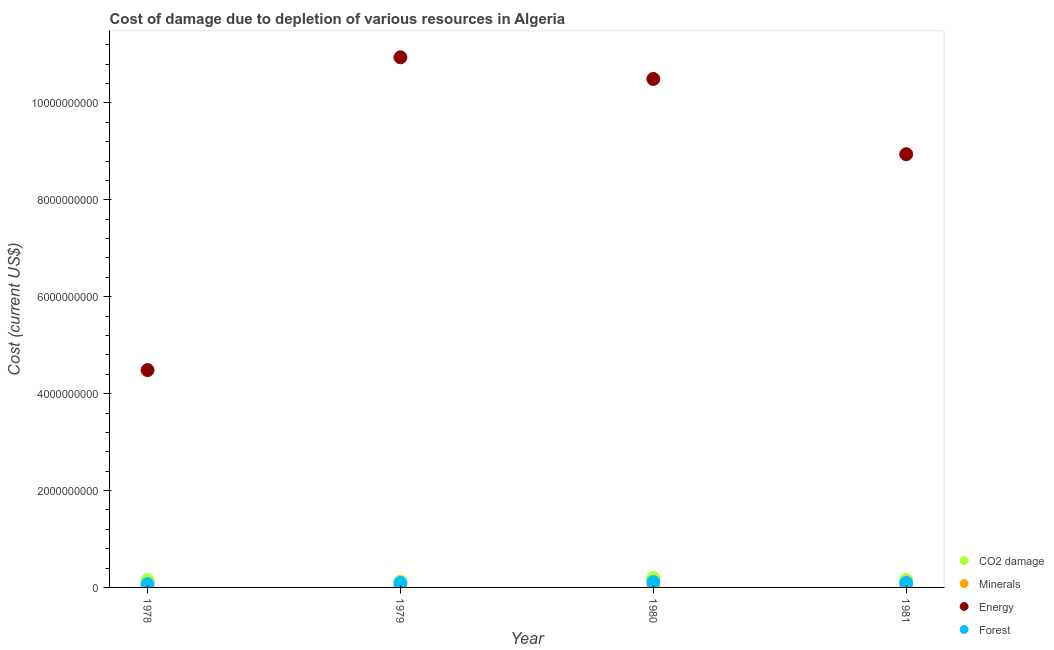How many different coloured dotlines are there?
Offer a terse response. 4. Is the number of dotlines equal to the number of legend labels?
Your response must be concise. Yes. What is the cost of damage due to depletion of minerals in 1980?
Ensure brevity in your answer.  1.57e+07. Across all years, what is the maximum cost of damage due to depletion of coal?
Give a very brief answer. 1.94e+08. Across all years, what is the minimum cost of damage due to depletion of forests?
Your answer should be very brief. 6.78e+07. In which year was the cost of damage due to depletion of energy maximum?
Your response must be concise. 1979. In which year was the cost of damage due to depletion of forests minimum?
Your answer should be very brief. 1978. What is the total cost of damage due to depletion of energy in the graph?
Provide a short and direct response. 3.49e+1. What is the difference between the cost of damage due to depletion of forests in 1979 and that in 1980?
Your answer should be very brief. -2.06e+07. What is the difference between the cost of damage due to depletion of energy in 1979 and the cost of damage due to depletion of forests in 1978?
Make the answer very short. 1.09e+1. What is the average cost of damage due to depletion of energy per year?
Your answer should be very brief. 8.72e+09. In the year 1980, what is the difference between the cost of damage due to depletion of minerals and cost of damage due to depletion of forests?
Offer a very short reply. -9.63e+07. In how many years, is the cost of damage due to depletion of minerals greater than 10000000000 US$?
Your answer should be very brief. 0. What is the ratio of the cost of damage due to depletion of forests in 1978 to that in 1979?
Offer a very short reply. 0.74. Is the difference between the cost of damage due to depletion of energy in 1978 and 1979 greater than the difference between the cost of damage due to depletion of minerals in 1978 and 1979?
Offer a very short reply. No. What is the difference between the highest and the second highest cost of damage due to depletion of energy?
Provide a succinct answer. 4.47e+08. What is the difference between the highest and the lowest cost of damage due to depletion of minerals?
Ensure brevity in your answer.  7.98e+06. In how many years, is the cost of damage due to depletion of coal greater than the average cost of damage due to depletion of coal taken over all years?
Ensure brevity in your answer.  1. Is the cost of damage due to depletion of forests strictly greater than the cost of damage due to depletion of energy over the years?
Provide a succinct answer. No. Is the cost of damage due to depletion of minerals strictly less than the cost of damage due to depletion of energy over the years?
Offer a terse response. Yes. What is the difference between two consecutive major ticks on the Y-axis?
Make the answer very short. 2.00e+09. Are the values on the major ticks of Y-axis written in scientific E-notation?
Give a very brief answer. No. Does the graph contain grids?
Offer a terse response. No. How many legend labels are there?
Ensure brevity in your answer.  4. How are the legend labels stacked?
Provide a succinct answer. Vertical. What is the title of the graph?
Your answer should be compact. Cost of damage due to depletion of various resources in Algeria . Does "Japan" appear as one of the legend labels in the graph?
Your response must be concise. No. What is the label or title of the Y-axis?
Your answer should be compact. Cost (current US$). What is the Cost (current US$) in CO2 damage in 1978?
Provide a succinct answer. 1.51e+08. What is the Cost (current US$) in Minerals in 1978?
Offer a terse response. 7.76e+06. What is the Cost (current US$) in Energy in 1978?
Offer a very short reply. 4.49e+09. What is the Cost (current US$) in Forest in 1978?
Your response must be concise. 6.78e+07. What is the Cost (current US$) in CO2 damage in 1979?
Make the answer very short. 1.21e+08. What is the Cost (current US$) in Minerals in 1979?
Offer a terse response. 9.02e+06. What is the Cost (current US$) in Energy in 1979?
Your response must be concise. 1.09e+1. What is the Cost (current US$) in Forest in 1979?
Your answer should be very brief. 9.15e+07. What is the Cost (current US$) in CO2 damage in 1980?
Provide a succinct answer. 1.94e+08. What is the Cost (current US$) of Minerals in 1980?
Offer a terse response. 1.57e+07. What is the Cost (current US$) in Energy in 1980?
Keep it short and to the point. 1.05e+1. What is the Cost (current US$) of Forest in 1980?
Ensure brevity in your answer.  1.12e+08. What is the Cost (current US$) of CO2 damage in 1981?
Provide a succinct answer. 1.50e+08. What is the Cost (current US$) in Minerals in 1981?
Offer a terse response. 1.55e+07. What is the Cost (current US$) in Energy in 1981?
Offer a very short reply. 8.94e+09. What is the Cost (current US$) in Forest in 1981?
Your answer should be very brief. 9.29e+07. Across all years, what is the maximum Cost (current US$) of CO2 damage?
Make the answer very short. 1.94e+08. Across all years, what is the maximum Cost (current US$) of Minerals?
Keep it short and to the point. 1.57e+07. Across all years, what is the maximum Cost (current US$) in Energy?
Provide a short and direct response. 1.09e+1. Across all years, what is the maximum Cost (current US$) in Forest?
Ensure brevity in your answer.  1.12e+08. Across all years, what is the minimum Cost (current US$) of CO2 damage?
Give a very brief answer. 1.21e+08. Across all years, what is the minimum Cost (current US$) of Minerals?
Keep it short and to the point. 7.76e+06. Across all years, what is the minimum Cost (current US$) of Energy?
Your response must be concise. 4.49e+09. Across all years, what is the minimum Cost (current US$) of Forest?
Your response must be concise. 6.78e+07. What is the total Cost (current US$) in CO2 damage in the graph?
Offer a terse response. 6.17e+08. What is the total Cost (current US$) in Minerals in the graph?
Provide a short and direct response. 4.80e+07. What is the total Cost (current US$) in Energy in the graph?
Your answer should be very brief. 3.49e+1. What is the total Cost (current US$) in Forest in the graph?
Give a very brief answer. 3.64e+08. What is the difference between the Cost (current US$) in CO2 damage in 1978 and that in 1979?
Provide a short and direct response. 3.04e+07. What is the difference between the Cost (current US$) in Minerals in 1978 and that in 1979?
Make the answer very short. -1.26e+06. What is the difference between the Cost (current US$) in Energy in 1978 and that in 1979?
Offer a terse response. -6.46e+09. What is the difference between the Cost (current US$) of Forest in 1978 and that in 1979?
Your response must be concise. -2.37e+07. What is the difference between the Cost (current US$) in CO2 damage in 1978 and that in 1980?
Offer a very short reply. -4.31e+07. What is the difference between the Cost (current US$) in Minerals in 1978 and that in 1980?
Give a very brief answer. -7.98e+06. What is the difference between the Cost (current US$) in Energy in 1978 and that in 1980?
Keep it short and to the point. -6.01e+09. What is the difference between the Cost (current US$) of Forest in 1978 and that in 1980?
Offer a terse response. -4.42e+07. What is the difference between the Cost (current US$) in CO2 damage in 1978 and that in 1981?
Your answer should be very brief. 1.13e+06. What is the difference between the Cost (current US$) of Minerals in 1978 and that in 1981?
Keep it short and to the point. -7.75e+06. What is the difference between the Cost (current US$) of Energy in 1978 and that in 1981?
Make the answer very short. -4.46e+09. What is the difference between the Cost (current US$) in Forest in 1978 and that in 1981?
Give a very brief answer. -2.50e+07. What is the difference between the Cost (current US$) of CO2 damage in 1979 and that in 1980?
Make the answer very short. -7.35e+07. What is the difference between the Cost (current US$) in Minerals in 1979 and that in 1980?
Offer a terse response. -6.72e+06. What is the difference between the Cost (current US$) of Energy in 1979 and that in 1980?
Make the answer very short. 4.47e+08. What is the difference between the Cost (current US$) in Forest in 1979 and that in 1980?
Give a very brief answer. -2.06e+07. What is the difference between the Cost (current US$) of CO2 damage in 1979 and that in 1981?
Provide a short and direct response. -2.92e+07. What is the difference between the Cost (current US$) in Minerals in 1979 and that in 1981?
Offer a very short reply. -6.50e+06. What is the difference between the Cost (current US$) in Energy in 1979 and that in 1981?
Provide a succinct answer. 2.00e+09. What is the difference between the Cost (current US$) in Forest in 1979 and that in 1981?
Your answer should be very brief. -1.38e+06. What is the difference between the Cost (current US$) in CO2 damage in 1980 and that in 1981?
Offer a very short reply. 4.43e+07. What is the difference between the Cost (current US$) of Minerals in 1980 and that in 1981?
Your answer should be very brief. 2.24e+05. What is the difference between the Cost (current US$) in Energy in 1980 and that in 1981?
Ensure brevity in your answer.  1.55e+09. What is the difference between the Cost (current US$) of Forest in 1980 and that in 1981?
Your answer should be very brief. 1.92e+07. What is the difference between the Cost (current US$) in CO2 damage in 1978 and the Cost (current US$) in Minerals in 1979?
Your answer should be compact. 1.42e+08. What is the difference between the Cost (current US$) of CO2 damage in 1978 and the Cost (current US$) of Energy in 1979?
Your answer should be compact. -1.08e+1. What is the difference between the Cost (current US$) of CO2 damage in 1978 and the Cost (current US$) of Forest in 1979?
Your answer should be compact. 5.97e+07. What is the difference between the Cost (current US$) in Minerals in 1978 and the Cost (current US$) in Energy in 1979?
Your answer should be compact. -1.09e+1. What is the difference between the Cost (current US$) of Minerals in 1978 and the Cost (current US$) of Forest in 1979?
Keep it short and to the point. -8.37e+07. What is the difference between the Cost (current US$) in Energy in 1978 and the Cost (current US$) in Forest in 1979?
Make the answer very short. 4.39e+09. What is the difference between the Cost (current US$) in CO2 damage in 1978 and the Cost (current US$) in Minerals in 1980?
Make the answer very short. 1.35e+08. What is the difference between the Cost (current US$) in CO2 damage in 1978 and the Cost (current US$) in Energy in 1980?
Provide a short and direct response. -1.03e+1. What is the difference between the Cost (current US$) in CO2 damage in 1978 and the Cost (current US$) in Forest in 1980?
Your answer should be compact. 3.92e+07. What is the difference between the Cost (current US$) of Minerals in 1978 and the Cost (current US$) of Energy in 1980?
Give a very brief answer. -1.05e+1. What is the difference between the Cost (current US$) in Minerals in 1978 and the Cost (current US$) in Forest in 1980?
Your answer should be compact. -1.04e+08. What is the difference between the Cost (current US$) of Energy in 1978 and the Cost (current US$) of Forest in 1980?
Provide a succinct answer. 4.37e+09. What is the difference between the Cost (current US$) of CO2 damage in 1978 and the Cost (current US$) of Minerals in 1981?
Provide a short and direct response. 1.36e+08. What is the difference between the Cost (current US$) of CO2 damage in 1978 and the Cost (current US$) of Energy in 1981?
Provide a succinct answer. -8.79e+09. What is the difference between the Cost (current US$) of CO2 damage in 1978 and the Cost (current US$) of Forest in 1981?
Your response must be concise. 5.84e+07. What is the difference between the Cost (current US$) in Minerals in 1978 and the Cost (current US$) in Energy in 1981?
Your response must be concise. -8.93e+09. What is the difference between the Cost (current US$) of Minerals in 1978 and the Cost (current US$) of Forest in 1981?
Your answer should be very brief. -8.51e+07. What is the difference between the Cost (current US$) in Energy in 1978 and the Cost (current US$) in Forest in 1981?
Provide a succinct answer. 4.39e+09. What is the difference between the Cost (current US$) in CO2 damage in 1979 and the Cost (current US$) in Minerals in 1980?
Your answer should be very brief. 1.05e+08. What is the difference between the Cost (current US$) of CO2 damage in 1979 and the Cost (current US$) of Energy in 1980?
Offer a very short reply. -1.04e+1. What is the difference between the Cost (current US$) in CO2 damage in 1979 and the Cost (current US$) in Forest in 1980?
Provide a succinct answer. 8.81e+06. What is the difference between the Cost (current US$) of Minerals in 1979 and the Cost (current US$) of Energy in 1980?
Your answer should be very brief. -1.05e+1. What is the difference between the Cost (current US$) of Minerals in 1979 and the Cost (current US$) of Forest in 1980?
Ensure brevity in your answer.  -1.03e+08. What is the difference between the Cost (current US$) of Energy in 1979 and the Cost (current US$) of Forest in 1980?
Offer a very short reply. 1.08e+1. What is the difference between the Cost (current US$) of CO2 damage in 1979 and the Cost (current US$) of Minerals in 1981?
Ensure brevity in your answer.  1.05e+08. What is the difference between the Cost (current US$) in CO2 damage in 1979 and the Cost (current US$) in Energy in 1981?
Keep it short and to the point. -8.82e+09. What is the difference between the Cost (current US$) in CO2 damage in 1979 and the Cost (current US$) in Forest in 1981?
Ensure brevity in your answer.  2.80e+07. What is the difference between the Cost (current US$) of Minerals in 1979 and the Cost (current US$) of Energy in 1981?
Offer a terse response. -8.93e+09. What is the difference between the Cost (current US$) of Minerals in 1979 and the Cost (current US$) of Forest in 1981?
Offer a terse response. -8.38e+07. What is the difference between the Cost (current US$) in Energy in 1979 and the Cost (current US$) in Forest in 1981?
Keep it short and to the point. 1.08e+1. What is the difference between the Cost (current US$) in CO2 damage in 1980 and the Cost (current US$) in Minerals in 1981?
Your answer should be very brief. 1.79e+08. What is the difference between the Cost (current US$) in CO2 damage in 1980 and the Cost (current US$) in Energy in 1981?
Provide a short and direct response. -8.75e+09. What is the difference between the Cost (current US$) in CO2 damage in 1980 and the Cost (current US$) in Forest in 1981?
Ensure brevity in your answer.  1.01e+08. What is the difference between the Cost (current US$) in Minerals in 1980 and the Cost (current US$) in Energy in 1981?
Your answer should be very brief. -8.93e+09. What is the difference between the Cost (current US$) in Minerals in 1980 and the Cost (current US$) in Forest in 1981?
Your answer should be very brief. -7.71e+07. What is the difference between the Cost (current US$) of Energy in 1980 and the Cost (current US$) of Forest in 1981?
Your answer should be compact. 1.04e+1. What is the average Cost (current US$) of CO2 damage per year?
Your answer should be compact. 1.54e+08. What is the average Cost (current US$) of Minerals per year?
Give a very brief answer. 1.20e+07. What is the average Cost (current US$) in Energy per year?
Keep it short and to the point. 8.72e+09. What is the average Cost (current US$) in Forest per year?
Your answer should be very brief. 9.11e+07. In the year 1978, what is the difference between the Cost (current US$) of CO2 damage and Cost (current US$) of Minerals?
Your answer should be compact. 1.43e+08. In the year 1978, what is the difference between the Cost (current US$) of CO2 damage and Cost (current US$) of Energy?
Give a very brief answer. -4.33e+09. In the year 1978, what is the difference between the Cost (current US$) of CO2 damage and Cost (current US$) of Forest?
Your response must be concise. 8.34e+07. In the year 1978, what is the difference between the Cost (current US$) of Minerals and Cost (current US$) of Energy?
Ensure brevity in your answer.  -4.48e+09. In the year 1978, what is the difference between the Cost (current US$) of Minerals and Cost (current US$) of Forest?
Offer a very short reply. -6.01e+07. In the year 1978, what is the difference between the Cost (current US$) in Energy and Cost (current US$) in Forest?
Your response must be concise. 4.42e+09. In the year 1979, what is the difference between the Cost (current US$) of CO2 damage and Cost (current US$) of Minerals?
Keep it short and to the point. 1.12e+08. In the year 1979, what is the difference between the Cost (current US$) of CO2 damage and Cost (current US$) of Energy?
Ensure brevity in your answer.  -1.08e+1. In the year 1979, what is the difference between the Cost (current US$) of CO2 damage and Cost (current US$) of Forest?
Keep it short and to the point. 2.94e+07. In the year 1979, what is the difference between the Cost (current US$) of Minerals and Cost (current US$) of Energy?
Your response must be concise. -1.09e+1. In the year 1979, what is the difference between the Cost (current US$) of Minerals and Cost (current US$) of Forest?
Give a very brief answer. -8.25e+07. In the year 1979, what is the difference between the Cost (current US$) in Energy and Cost (current US$) in Forest?
Offer a very short reply. 1.09e+1. In the year 1980, what is the difference between the Cost (current US$) of CO2 damage and Cost (current US$) of Minerals?
Your answer should be very brief. 1.79e+08. In the year 1980, what is the difference between the Cost (current US$) of CO2 damage and Cost (current US$) of Energy?
Make the answer very short. -1.03e+1. In the year 1980, what is the difference between the Cost (current US$) of CO2 damage and Cost (current US$) of Forest?
Your answer should be compact. 8.23e+07. In the year 1980, what is the difference between the Cost (current US$) in Minerals and Cost (current US$) in Energy?
Give a very brief answer. -1.05e+1. In the year 1980, what is the difference between the Cost (current US$) of Minerals and Cost (current US$) of Forest?
Ensure brevity in your answer.  -9.63e+07. In the year 1980, what is the difference between the Cost (current US$) in Energy and Cost (current US$) in Forest?
Keep it short and to the point. 1.04e+1. In the year 1981, what is the difference between the Cost (current US$) of CO2 damage and Cost (current US$) of Minerals?
Give a very brief answer. 1.35e+08. In the year 1981, what is the difference between the Cost (current US$) in CO2 damage and Cost (current US$) in Energy?
Offer a terse response. -8.79e+09. In the year 1981, what is the difference between the Cost (current US$) of CO2 damage and Cost (current US$) of Forest?
Provide a short and direct response. 5.72e+07. In the year 1981, what is the difference between the Cost (current US$) in Minerals and Cost (current US$) in Energy?
Keep it short and to the point. -8.93e+09. In the year 1981, what is the difference between the Cost (current US$) of Minerals and Cost (current US$) of Forest?
Provide a short and direct response. -7.74e+07. In the year 1981, what is the difference between the Cost (current US$) of Energy and Cost (current US$) of Forest?
Offer a terse response. 8.85e+09. What is the ratio of the Cost (current US$) in CO2 damage in 1978 to that in 1979?
Offer a terse response. 1.25. What is the ratio of the Cost (current US$) of Minerals in 1978 to that in 1979?
Your answer should be compact. 0.86. What is the ratio of the Cost (current US$) in Energy in 1978 to that in 1979?
Ensure brevity in your answer.  0.41. What is the ratio of the Cost (current US$) of Forest in 1978 to that in 1979?
Your response must be concise. 0.74. What is the ratio of the Cost (current US$) in CO2 damage in 1978 to that in 1980?
Ensure brevity in your answer.  0.78. What is the ratio of the Cost (current US$) of Minerals in 1978 to that in 1980?
Your answer should be compact. 0.49. What is the ratio of the Cost (current US$) of Energy in 1978 to that in 1980?
Your answer should be very brief. 0.43. What is the ratio of the Cost (current US$) of Forest in 1978 to that in 1980?
Keep it short and to the point. 0.61. What is the ratio of the Cost (current US$) in CO2 damage in 1978 to that in 1981?
Your answer should be very brief. 1.01. What is the ratio of the Cost (current US$) in Minerals in 1978 to that in 1981?
Offer a very short reply. 0.5. What is the ratio of the Cost (current US$) of Energy in 1978 to that in 1981?
Make the answer very short. 0.5. What is the ratio of the Cost (current US$) of Forest in 1978 to that in 1981?
Provide a succinct answer. 0.73. What is the ratio of the Cost (current US$) in CO2 damage in 1979 to that in 1980?
Your answer should be very brief. 0.62. What is the ratio of the Cost (current US$) of Minerals in 1979 to that in 1980?
Your response must be concise. 0.57. What is the ratio of the Cost (current US$) in Energy in 1979 to that in 1980?
Offer a very short reply. 1.04. What is the ratio of the Cost (current US$) in Forest in 1979 to that in 1980?
Ensure brevity in your answer.  0.82. What is the ratio of the Cost (current US$) of CO2 damage in 1979 to that in 1981?
Give a very brief answer. 0.81. What is the ratio of the Cost (current US$) of Minerals in 1979 to that in 1981?
Your response must be concise. 0.58. What is the ratio of the Cost (current US$) in Energy in 1979 to that in 1981?
Give a very brief answer. 1.22. What is the ratio of the Cost (current US$) of Forest in 1979 to that in 1981?
Ensure brevity in your answer.  0.99. What is the ratio of the Cost (current US$) in CO2 damage in 1980 to that in 1981?
Your answer should be compact. 1.29. What is the ratio of the Cost (current US$) of Minerals in 1980 to that in 1981?
Provide a short and direct response. 1.01. What is the ratio of the Cost (current US$) of Energy in 1980 to that in 1981?
Keep it short and to the point. 1.17. What is the ratio of the Cost (current US$) in Forest in 1980 to that in 1981?
Ensure brevity in your answer.  1.21. What is the difference between the highest and the second highest Cost (current US$) in CO2 damage?
Provide a succinct answer. 4.31e+07. What is the difference between the highest and the second highest Cost (current US$) of Minerals?
Make the answer very short. 2.24e+05. What is the difference between the highest and the second highest Cost (current US$) in Energy?
Ensure brevity in your answer.  4.47e+08. What is the difference between the highest and the second highest Cost (current US$) in Forest?
Your answer should be very brief. 1.92e+07. What is the difference between the highest and the lowest Cost (current US$) of CO2 damage?
Your response must be concise. 7.35e+07. What is the difference between the highest and the lowest Cost (current US$) in Minerals?
Provide a succinct answer. 7.98e+06. What is the difference between the highest and the lowest Cost (current US$) of Energy?
Provide a succinct answer. 6.46e+09. What is the difference between the highest and the lowest Cost (current US$) of Forest?
Your response must be concise. 4.42e+07. 